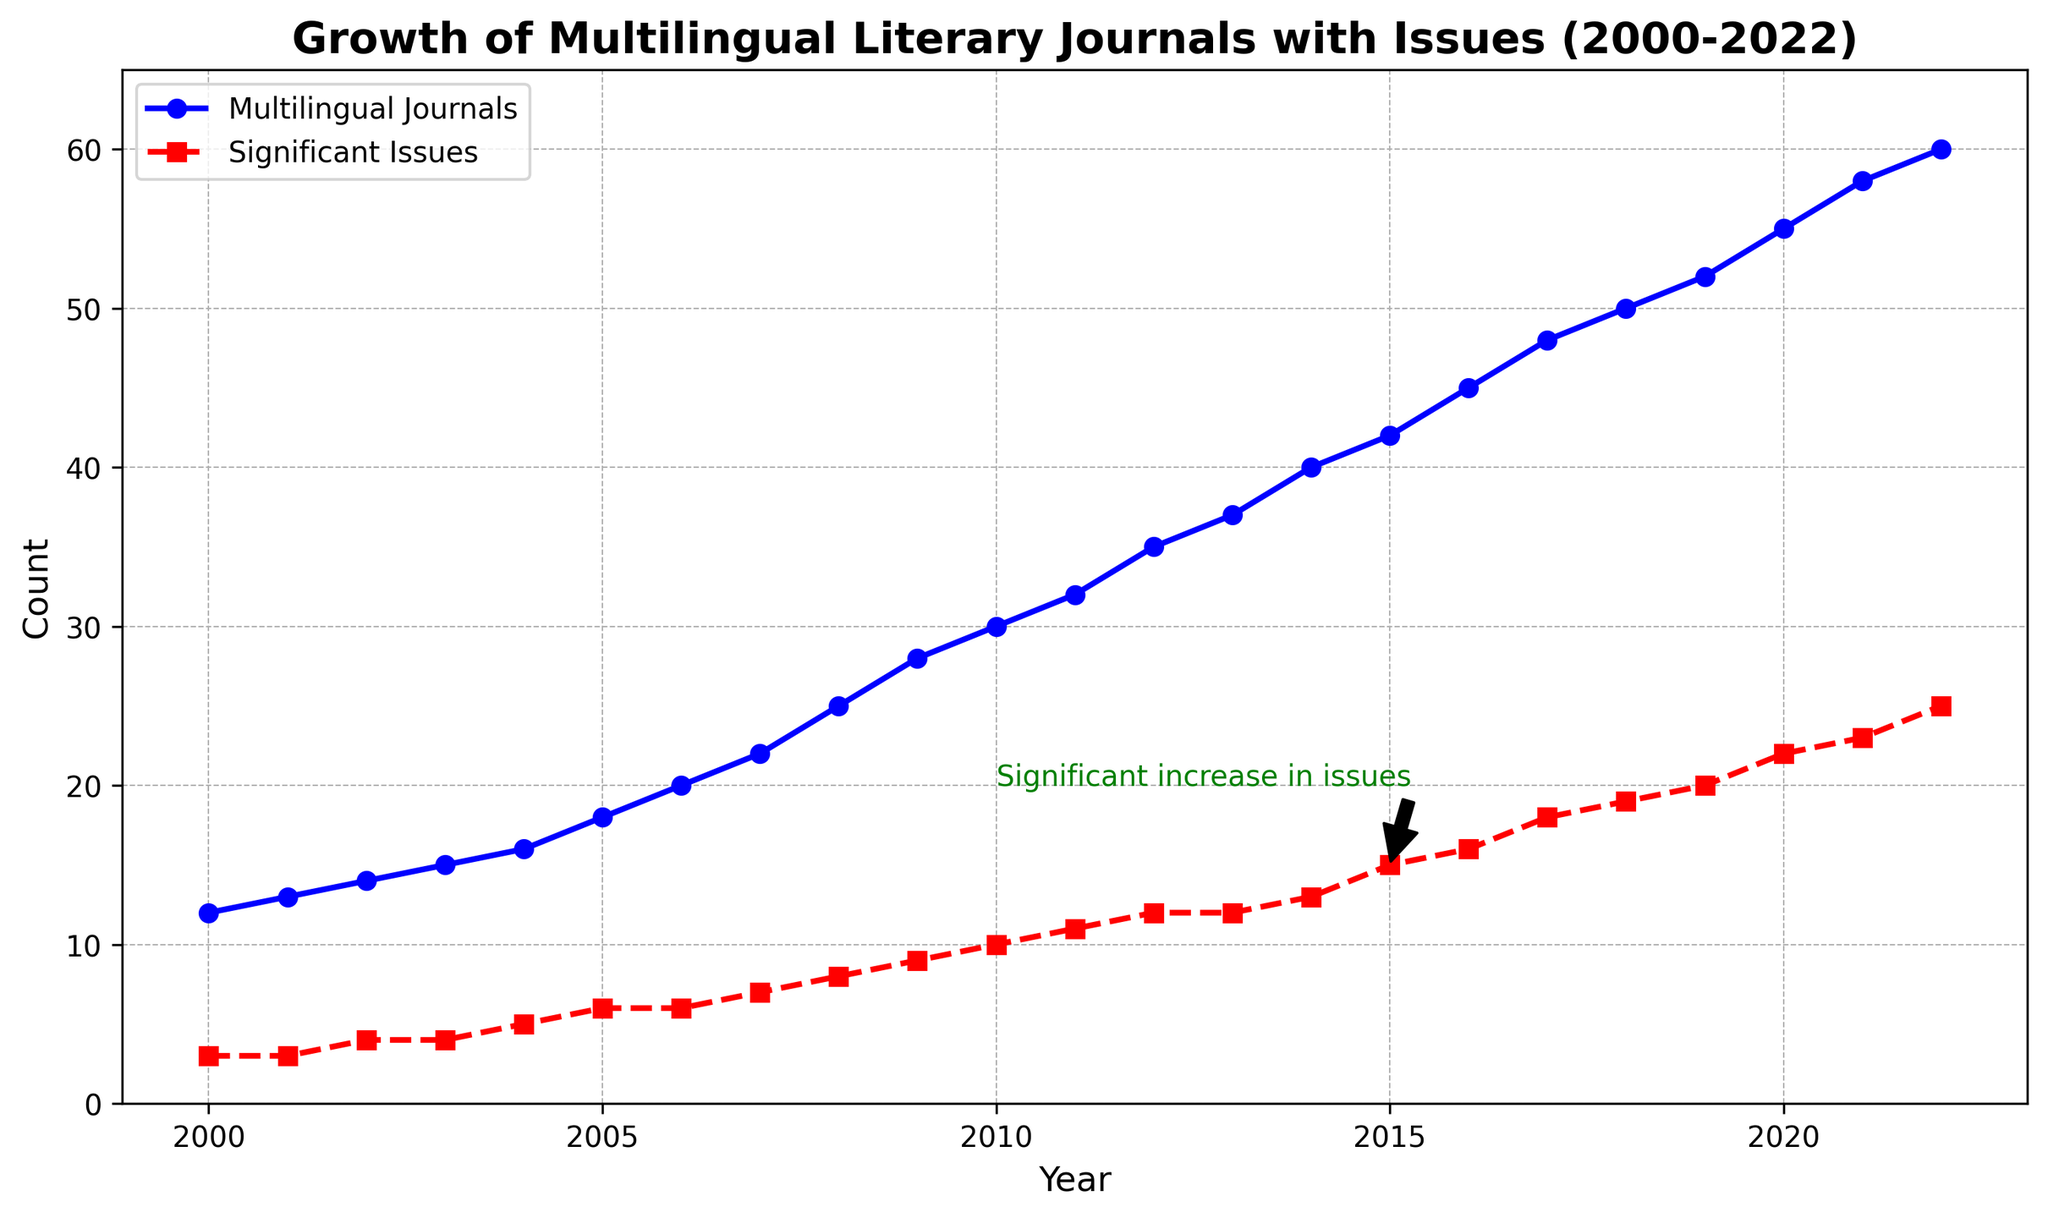How many Multilingual Journals were there in 2015? Look at the blue line on the graph where the year is 2015. The value next to the dot represents the number of journals.
Answer: 42 How many Significant Issues were there in 2015? Refer to the red dashed line on the graph for the year 2015. The value close to the red square marker will tell you the number of significant issues.
Answer: 15 What is the visual color representing Significant Issues? Observe the color used for the line plotting Significant Issues. It’s the dashed line and colored in red.
Answer: Red In which year did Multilingual Journals first reach 30? Look at the blue line and track the value of 30 on the y-axis, then find the corresponding year on the x-axis.
Answer: 2010 Which had a higher increase from 2000 to 2010, Multilingual Journals or Significant Issues? Calculate the increase for both lines between 2000 and 2010. For Multilingual Journals: 30 - 12 = 18. For Significant Issues: 10 - 3 = 7. Compare the two results.
Answer: Multilingual Journals From 2005 to 2022, which year saw the sharpest increase in Significant Issues? Look at the red dashed line and find the steepest upward slope between two consecutive years from 2005 to 2022. The sharpest increase is seen from 2019 (20) to 2020 (22), making it 2 issues.
Answer: 2020 What is the annotation pointing out in the graph? Look for the green annotation text and the arrow to see the specific message. It notes a "Significant increase in issues" around the year 2015.
Answer: Significant increase in issues around 2015 How many Multilingual Journals were added between 2015 and 2018? Note the number of journals in 2015 (42) and in 2018 (50). Subtract the earlier value from the later value.
50 - 42 = 8
Answer: 8 By how many did the Significant Issues increase from 2010 to 2012? Observe the red dashed line values in both 2010 (10) and 2012 (12). Subtract the 2010 value from the 2012 value.
12 - 10 = 2
Answer: 2 